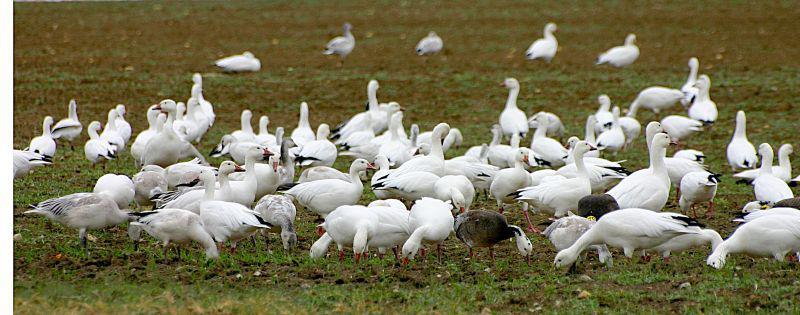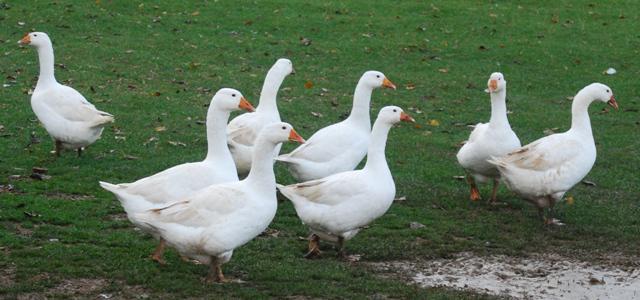The first image is the image on the left, the second image is the image on the right. Assess this claim about the two images: "There are no more than 4 animals in one of the images.". Correct or not? Answer yes or no. No. The first image is the image on the left, the second image is the image on the right. Evaluate the accuracy of this statement regarding the images: "There is at least one human pictured with a group of birds.". Is it true? Answer yes or no. No. 